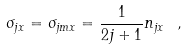Convert formula to latex. <formula><loc_0><loc_0><loc_500><loc_500>\sigma _ { j x } = \sigma _ { j m x } = \frac { 1 } { 2 j + 1 } n _ { j x } \ ,</formula> 